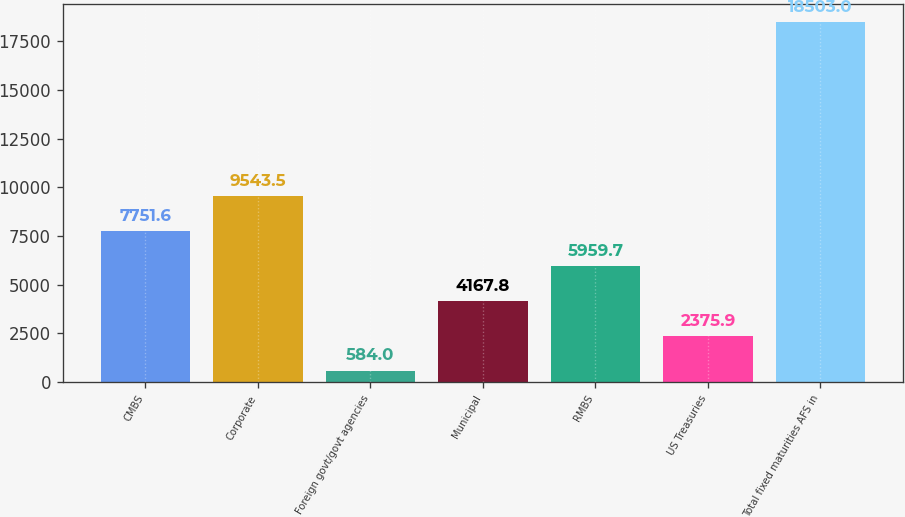Convert chart to OTSL. <chart><loc_0><loc_0><loc_500><loc_500><bar_chart><fcel>CMBS<fcel>Corporate<fcel>Foreign govt/govt agencies<fcel>Municipal<fcel>RMBS<fcel>US Treasuries<fcel>Total fixed maturities AFS in<nl><fcel>7751.6<fcel>9543.5<fcel>584<fcel>4167.8<fcel>5959.7<fcel>2375.9<fcel>18503<nl></chart> 